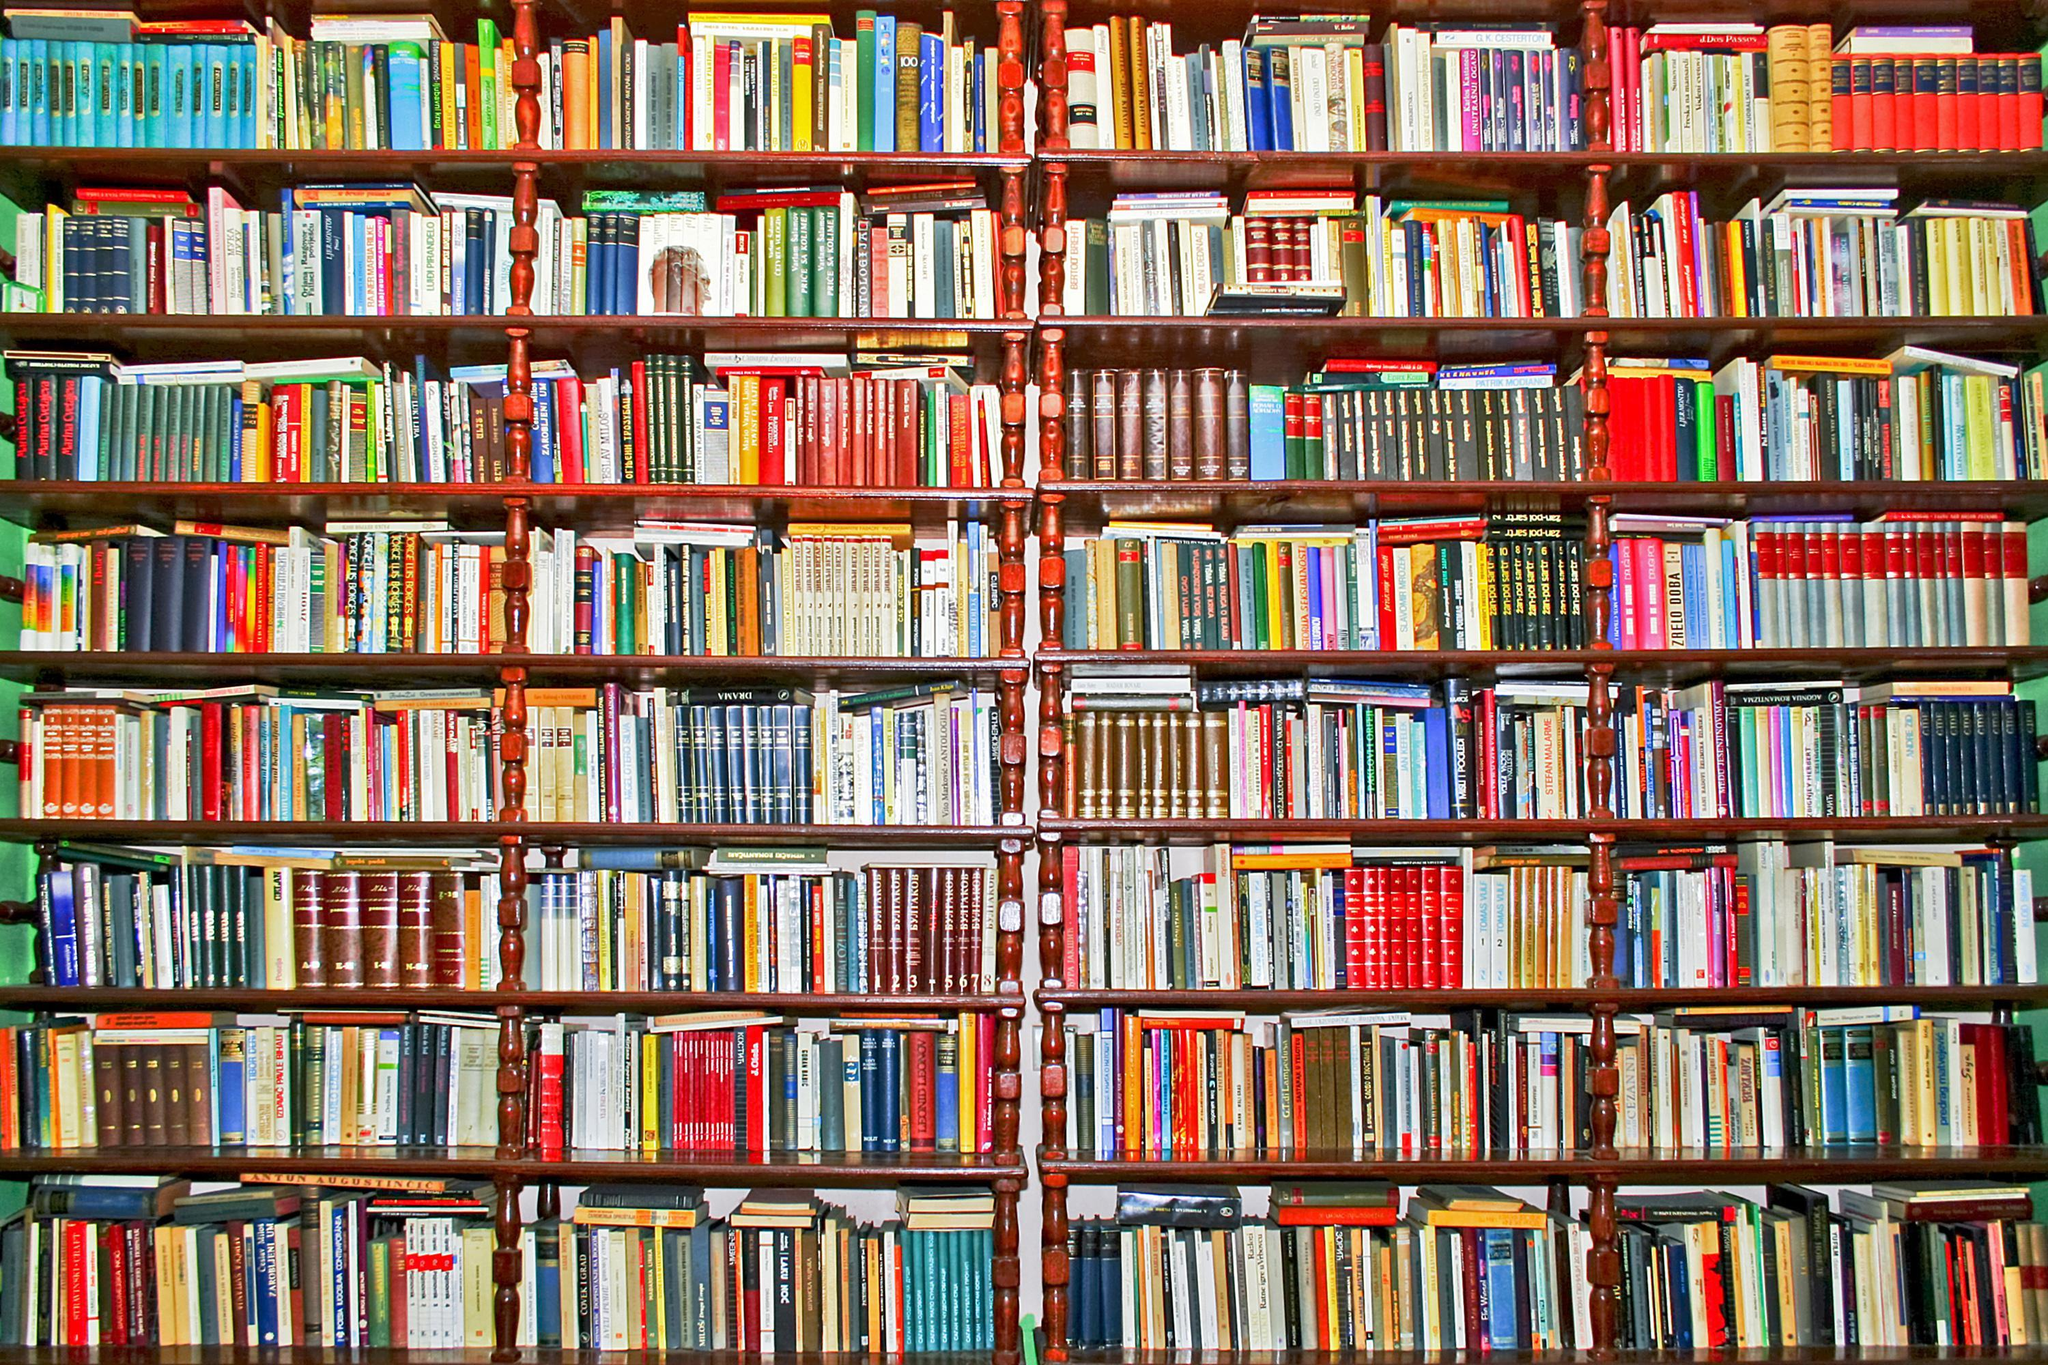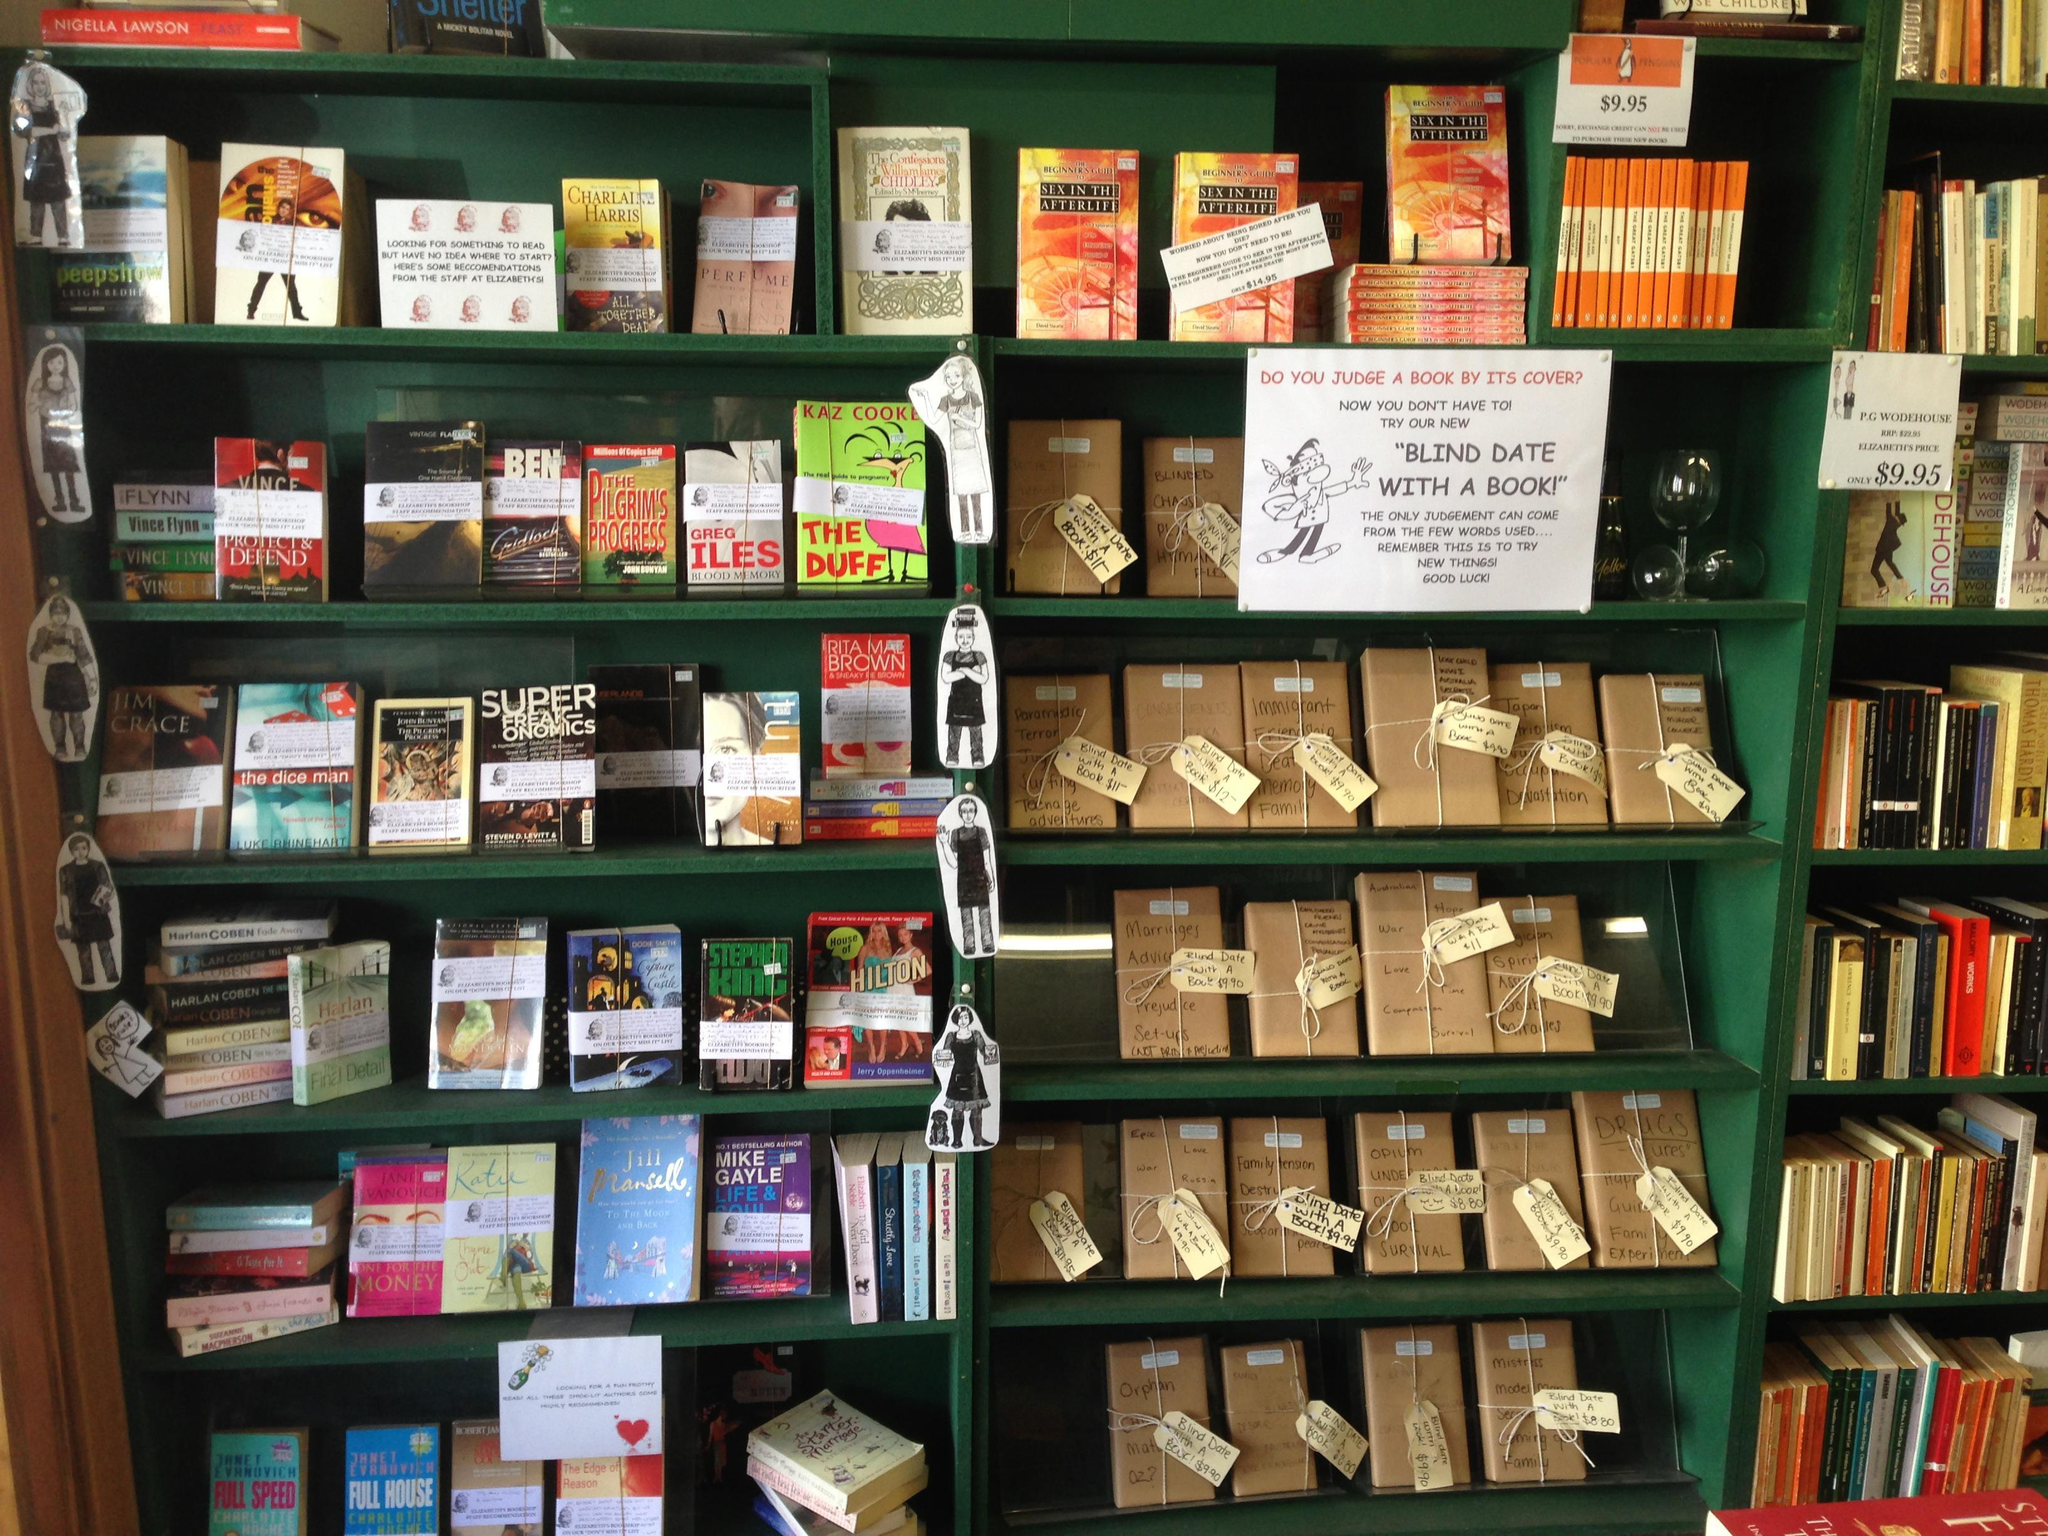The first image is the image on the left, the second image is the image on the right. Assess this claim about the two images: "The right image shows no more than six shelves of books and no shelves have white labels on their edges.". Correct or not? Answer yes or no. No. 